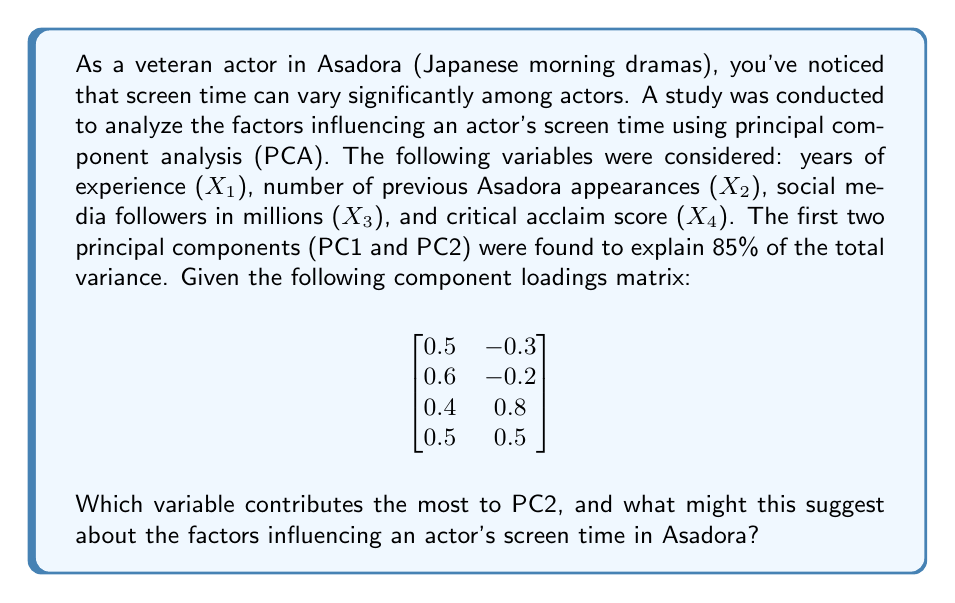Show me your answer to this math problem. To determine which variable contributes the most to PC2, we need to examine the component loadings for PC2 (the second column of the matrix). The loadings represent the correlation between each variable and the principal component.

The loadings for PC2 are:
X1: -0.3
X2: -0.2
X3: 0.8
X4: 0.5

The variable with the highest absolute loading value for PC2 is X3 (social media followers) with a loading of 0.8.

To interpret this result:

1. PC2 has a strong positive correlation with social media followers (0.8) and a moderate positive correlation with critical acclaim score (0.5).
2. PC2 has weak negative correlations with years of experience (-0.3) and number of previous Asadora appearances (-0.2).

This suggests that PC2 might represent a dimension of "current popularity and critical success" that is somewhat independent of traditional experience measures.

In the context of Asadora and actor screen time, this result implies that:

1. Social media following has a significant impact on an actor's screen time, possibly reflecting the production's desire to attract younger viewers or leverage an actor's existing fan base.
2. Critical acclaim also plays a role, suggesting that well-reviewed actors may be given more screen time.
3. Traditional measures of experience (years in the industry and previous Asadora appearances) are less important for this component, which could indicate a shift towards valuing current popularity over long-term experience in determining screen time.

This analysis provides insight into the changing dynamics of Japanese television, where social media presence and critical reception may be becoming increasingly important factors in determining an actor's prominence in Asadora productions.
Answer: The variable that contributes the most to PC2 is X3 (social media followers), with a loading of 0.8. This suggests that an actor's social media presence and current popularity are significant factors influencing screen time in Asadora, potentially more so than traditional measures of experience. 